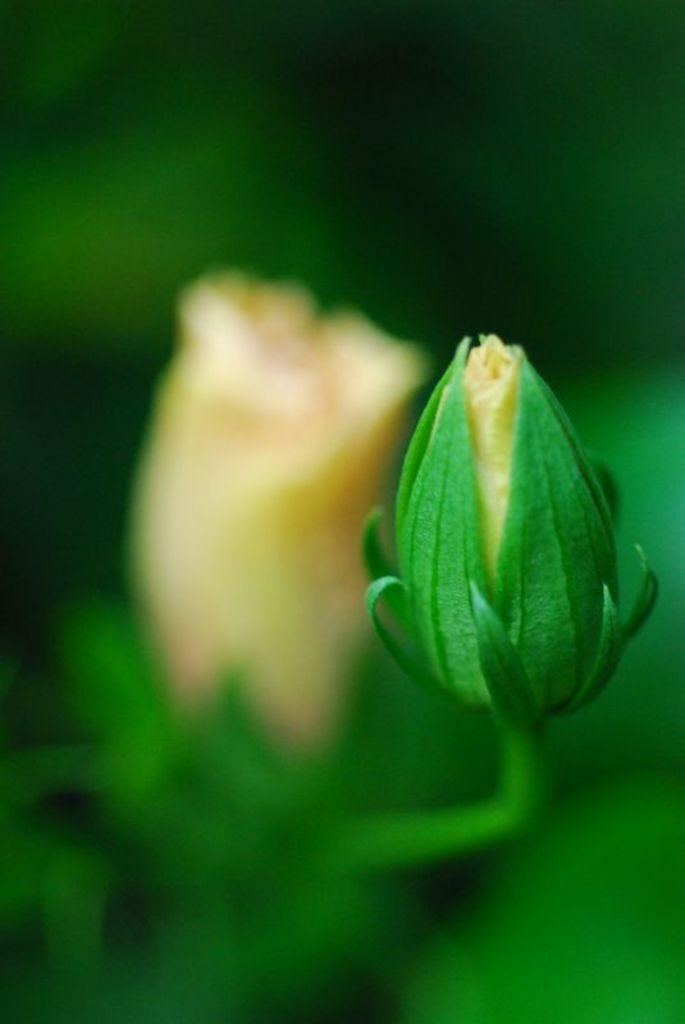What is the main subject in the middle of the image? There is a flower bud in the middle of the image. Can you describe the background of the image? There is a flower in the background of the image. How many baskets are hanging from the flower in the background? There are no baskets present in the image. What type of ticket can be seen near the flower bud? There is no ticket present in the image. 